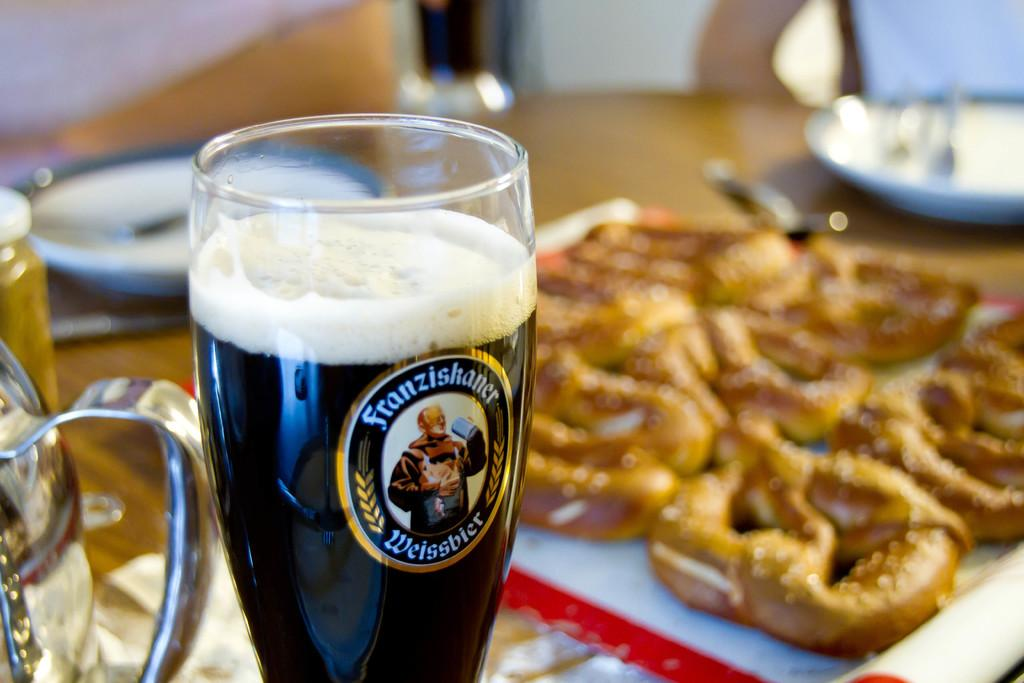What is the primary object visible in the image? There is a glass in the image. What else can be seen in the image besides the glass? There are food items, plates, and spoons visible in the image. What is the color of the table in the image? The table in the image is brown. What is the color of the food in the image? The food in the image is brown in color. Are there any insects crawling on the back of the table in the image? There is no mention of insects or the back of the table in the provided facts, so we cannot determine if there are any insects present. 